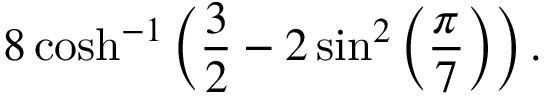Convert formula to latex. <formula><loc_0><loc_0><loc_500><loc_500>8 \cosh ^ { - 1 } \left ( { \frac { 3 } { 2 } } - 2 \sin ^ { 2 } \left ( { \frac { \pi } { 7 } } \right ) \right ) .</formula> 